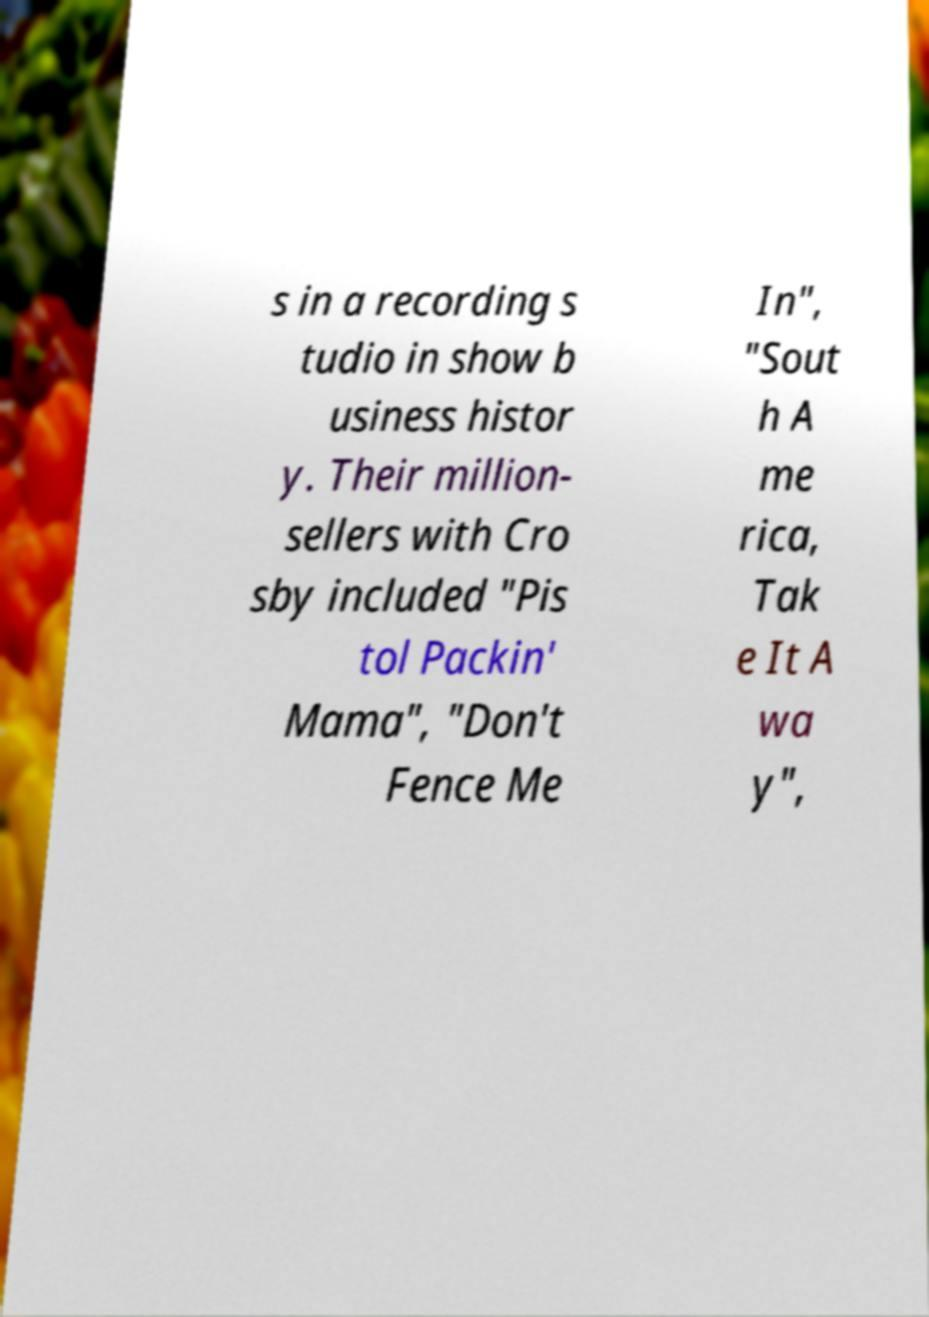Can you accurately transcribe the text from the provided image for me? s in a recording s tudio in show b usiness histor y. Their million- sellers with Cro sby included "Pis tol Packin' Mama", "Don't Fence Me In", "Sout h A me rica, Tak e It A wa y", 